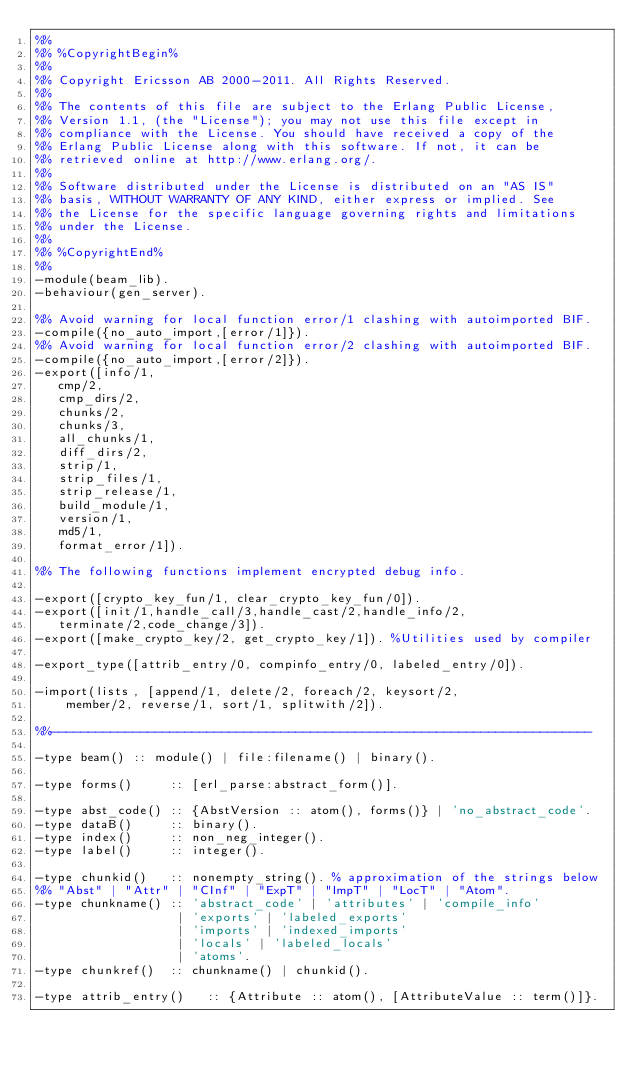Convert code to text. <code><loc_0><loc_0><loc_500><loc_500><_Erlang_>%%
%% %CopyrightBegin%
%%
%% Copyright Ericsson AB 2000-2011. All Rights Reserved.
%%
%% The contents of this file are subject to the Erlang Public License,
%% Version 1.1, (the "License"); you may not use this file except in
%% compliance with the License. You should have received a copy of the
%% Erlang Public License along with this software. If not, it can be
%% retrieved online at http://www.erlang.org/.
%%
%% Software distributed under the License is distributed on an "AS IS"
%% basis, WITHOUT WARRANTY OF ANY KIND, either express or implied. See
%% the License for the specific language governing rights and limitations
%% under the License.
%%
%% %CopyrightEnd%
%%
-module(beam_lib).
-behaviour(gen_server).

%% Avoid warning for local function error/1 clashing with autoimported BIF.
-compile({no_auto_import,[error/1]}).
%% Avoid warning for local function error/2 clashing with autoimported BIF.
-compile({no_auto_import,[error/2]}).
-export([info/1,
	 cmp/2,
	 cmp_dirs/2,
	 chunks/2,
	 chunks/3,
	 all_chunks/1,
	 diff_dirs/2,
	 strip/1,
	 strip_files/1,
	 strip_release/1,
	 build_module/1,
	 version/1,
	 md5/1,
	 format_error/1]).

%% The following functions implement encrypted debug info.

-export([crypto_key_fun/1, clear_crypto_key_fun/0]).
-export([init/1,handle_call/3,handle_cast/2,handle_info/2,
	 terminate/2,code_change/3]).
-export([make_crypto_key/2, get_crypto_key/1]).	%Utilities used by compiler

-export_type([attrib_entry/0, compinfo_entry/0, labeled_entry/0]).

-import(lists, [append/1, delete/2, foreach/2, keysort/2, 
		member/2, reverse/1, sort/1, splitwith/2]).

%%-------------------------------------------------------------------------

-type beam() :: module() | file:filename() | binary().

-type forms()     :: [erl_parse:abstract_form()].

-type abst_code() :: {AbstVersion :: atom(), forms()} | 'no_abstract_code'.
-type dataB()     :: binary().
-type index()     :: non_neg_integer().
-type label()     :: integer().

-type chunkid()   :: nonempty_string(). % approximation of the strings below
%% "Abst" | "Attr" | "CInf" | "ExpT" | "ImpT" | "LocT" | "Atom".
-type chunkname() :: 'abstract_code' | 'attributes' | 'compile_info'
                   | 'exports' | 'labeled_exports'
                   | 'imports' | 'indexed_imports'
                   | 'locals' | 'labeled_locals'
                   | 'atoms'.
-type chunkref()  :: chunkname() | chunkid().

-type attrib_entry()   :: {Attribute :: atom(), [AttributeValue :: term()]}.</code> 